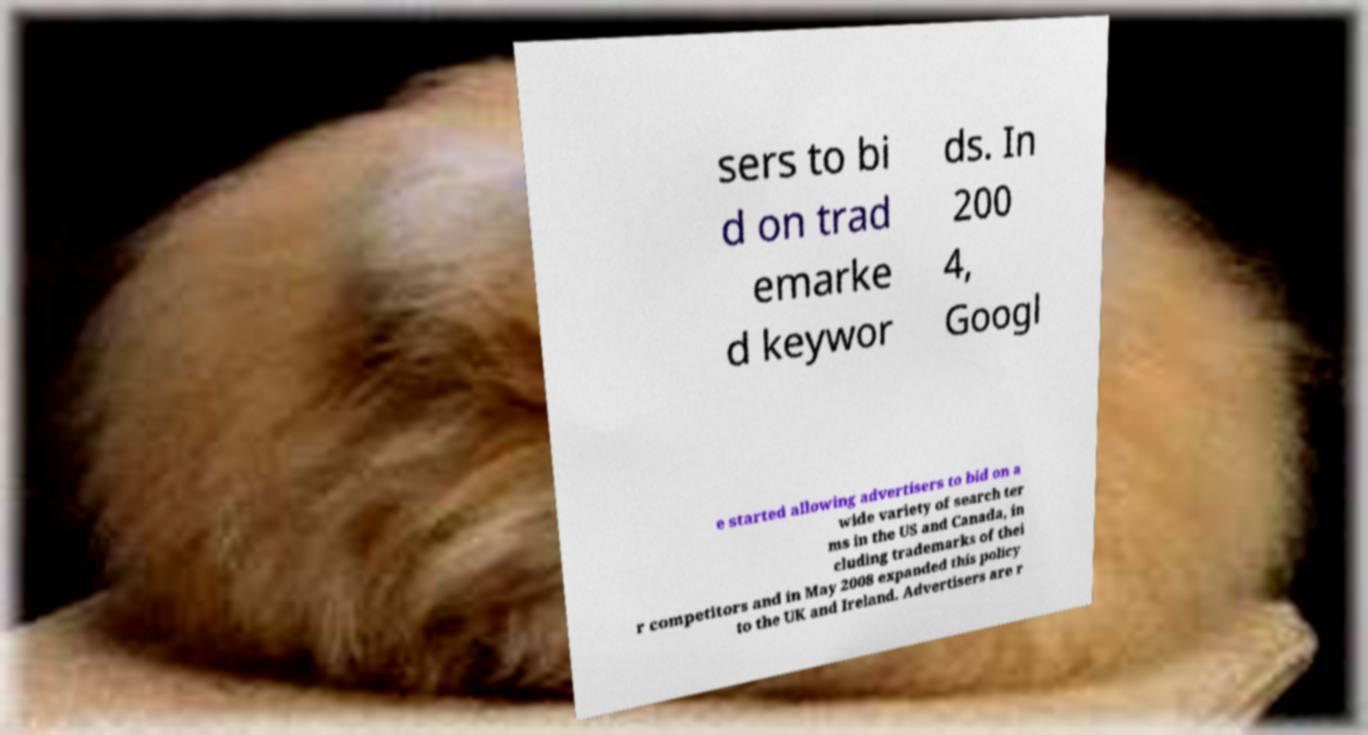Can you read and provide the text displayed in the image?This photo seems to have some interesting text. Can you extract and type it out for me? sers to bi d on trad emarke d keywor ds. In 200 4, Googl e started allowing advertisers to bid on a wide variety of search ter ms in the US and Canada, in cluding trademarks of thei r competitors and in May 2008 expanded this policy to the UK and Ireland. Advertisers are r 